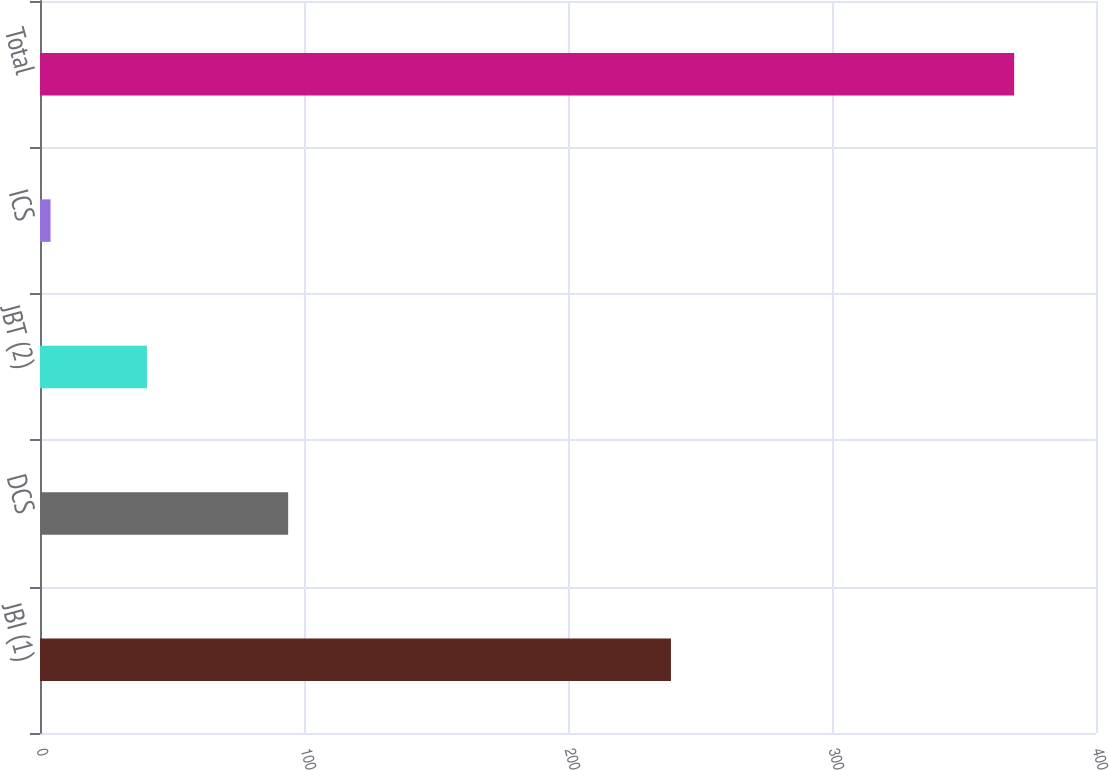Convert chart to OTSL. <chart><loc_0><loc_0><loc_500><loc_500><bar_chart><fcel>JBI (1)<fcel>DCS<fcel>JBT (2)<fcel>ICS<fcel>Total<nl><fcel>239<fcel>94<fcel>40.5<fcel>4<fcel>369<nl></chart> 